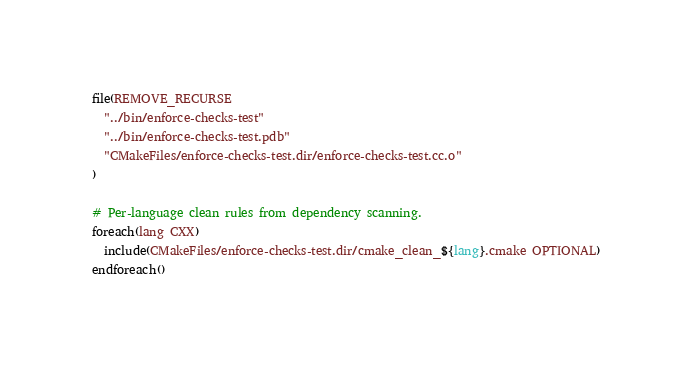Convert code to text. <code><loc_0><loc_0><loc_500><loc_500><_CMake_>file(REMOVE_RECURSE
  "../bin/enforce-checks-test"
  "../bin/enforce-checks-test.pdb"
  "CMakeFiles/enforce-checks-test.dir/enforce-checks-test.cc.o"
)

# Per-language clean rules from dependency scanning.
foreach(lang CXX)
  include(CMakeFiles/enforce-checks-test.dir/cmake_clean_${lang}.cmake OPTIONAL)
endforeach()
</code> 